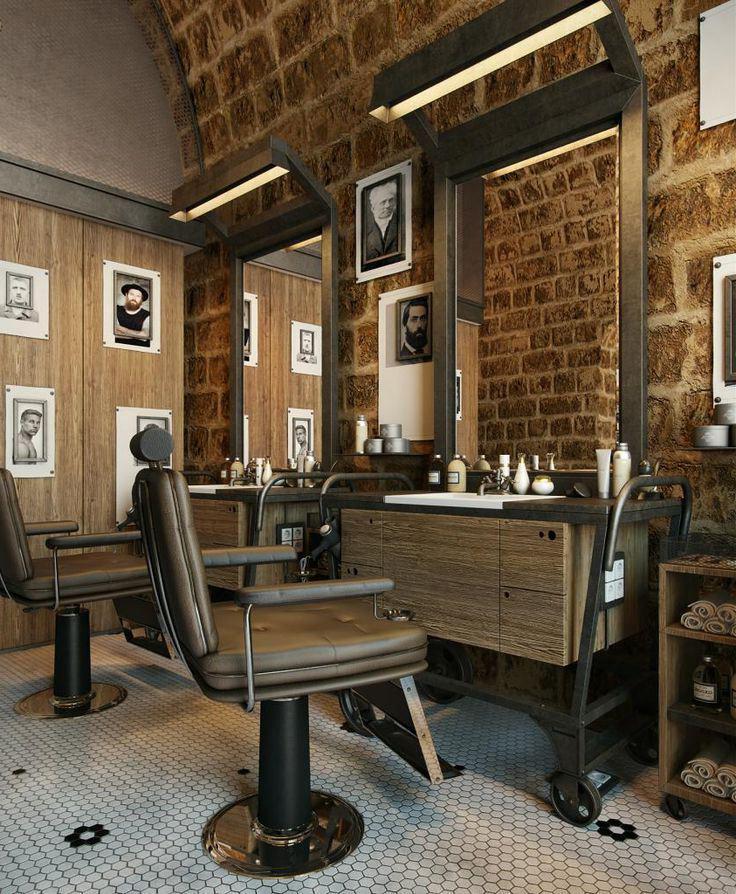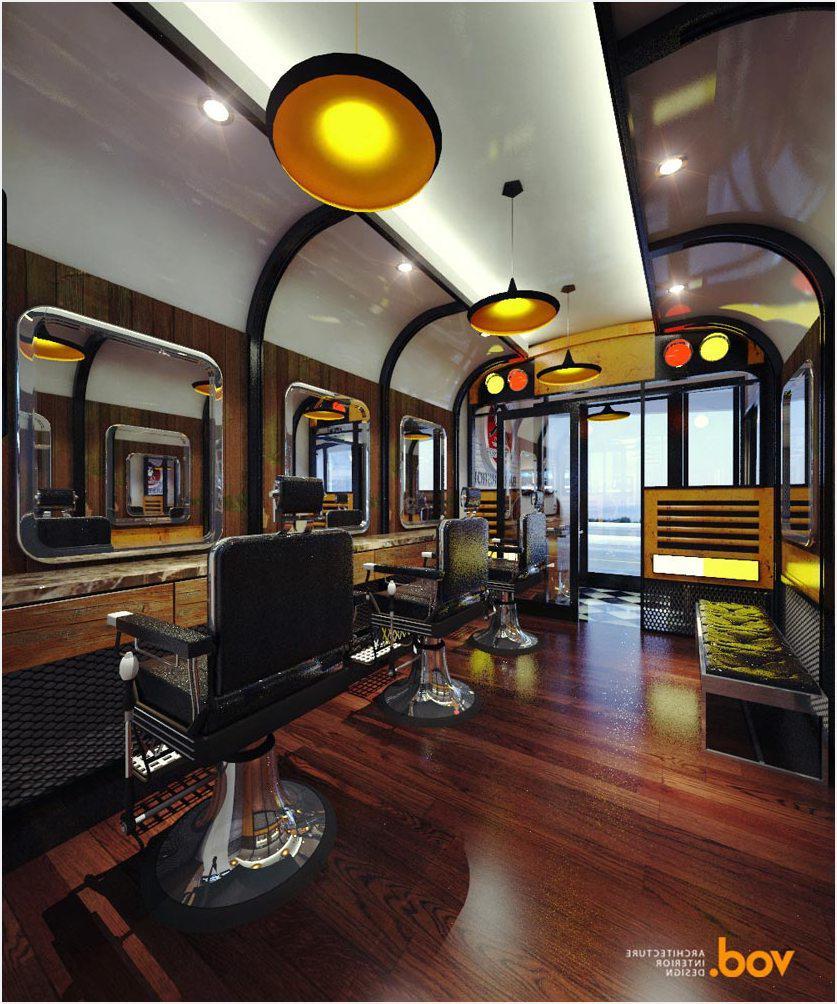The first image is the image on the left, the second image is the image on the right. Given the left and right images, does the statement "A row of five black barber chairs faces the camera in one image." hold true? Answer yes or no. No. 